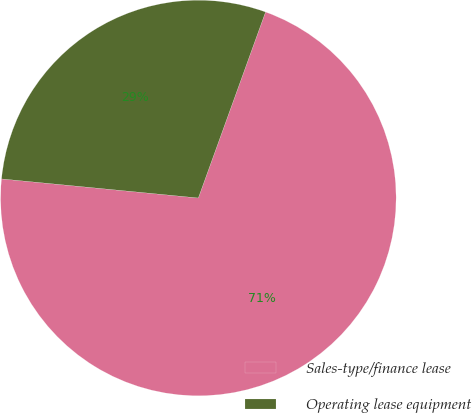Convert chart. <chart><loc_0><loc_0><loc_500><loc_500><pie_chart><fcel>Sales-type/finance lease<fcel>Operating lease equipment<nl><fcel>71.02%<fcel>28.98%<nl></chart> 